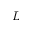Convert formula to latex. <formula><loc_0><loc_0><loc_500><loc_500>L</formula> 